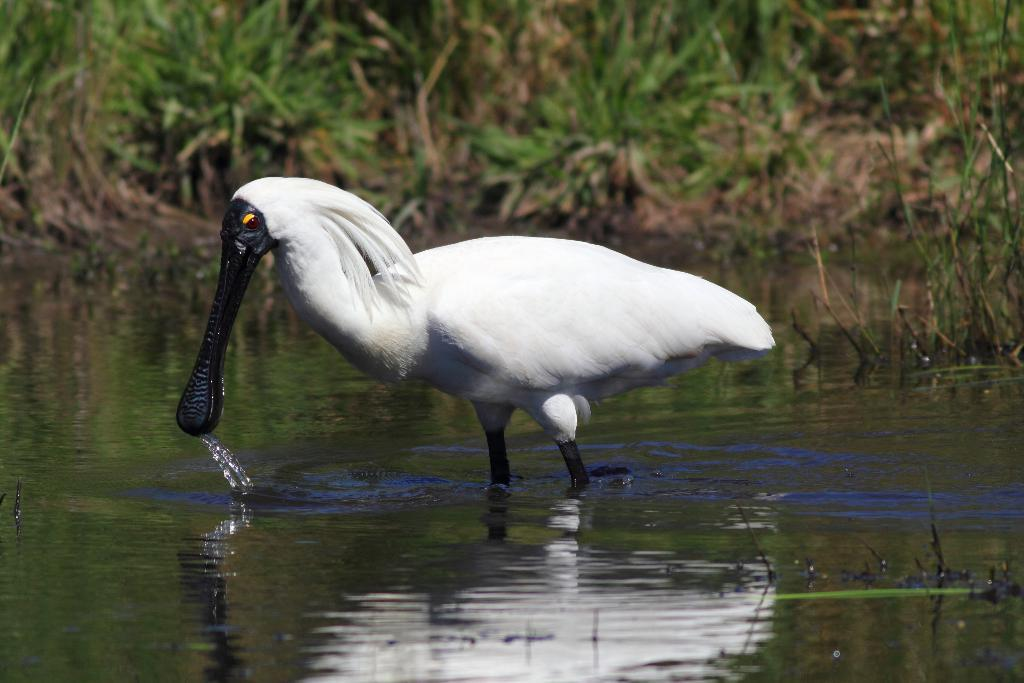What type of animal can be seen in the water in the image? There is a white color bird in the water in the image. What can be seen in the background of the image? There are planets and grass visible in the background. How is the background of the image depicted? The background of the image is blurred. What type of wool is being used to create the ice in the image? There is no wool or ice present in the image. 